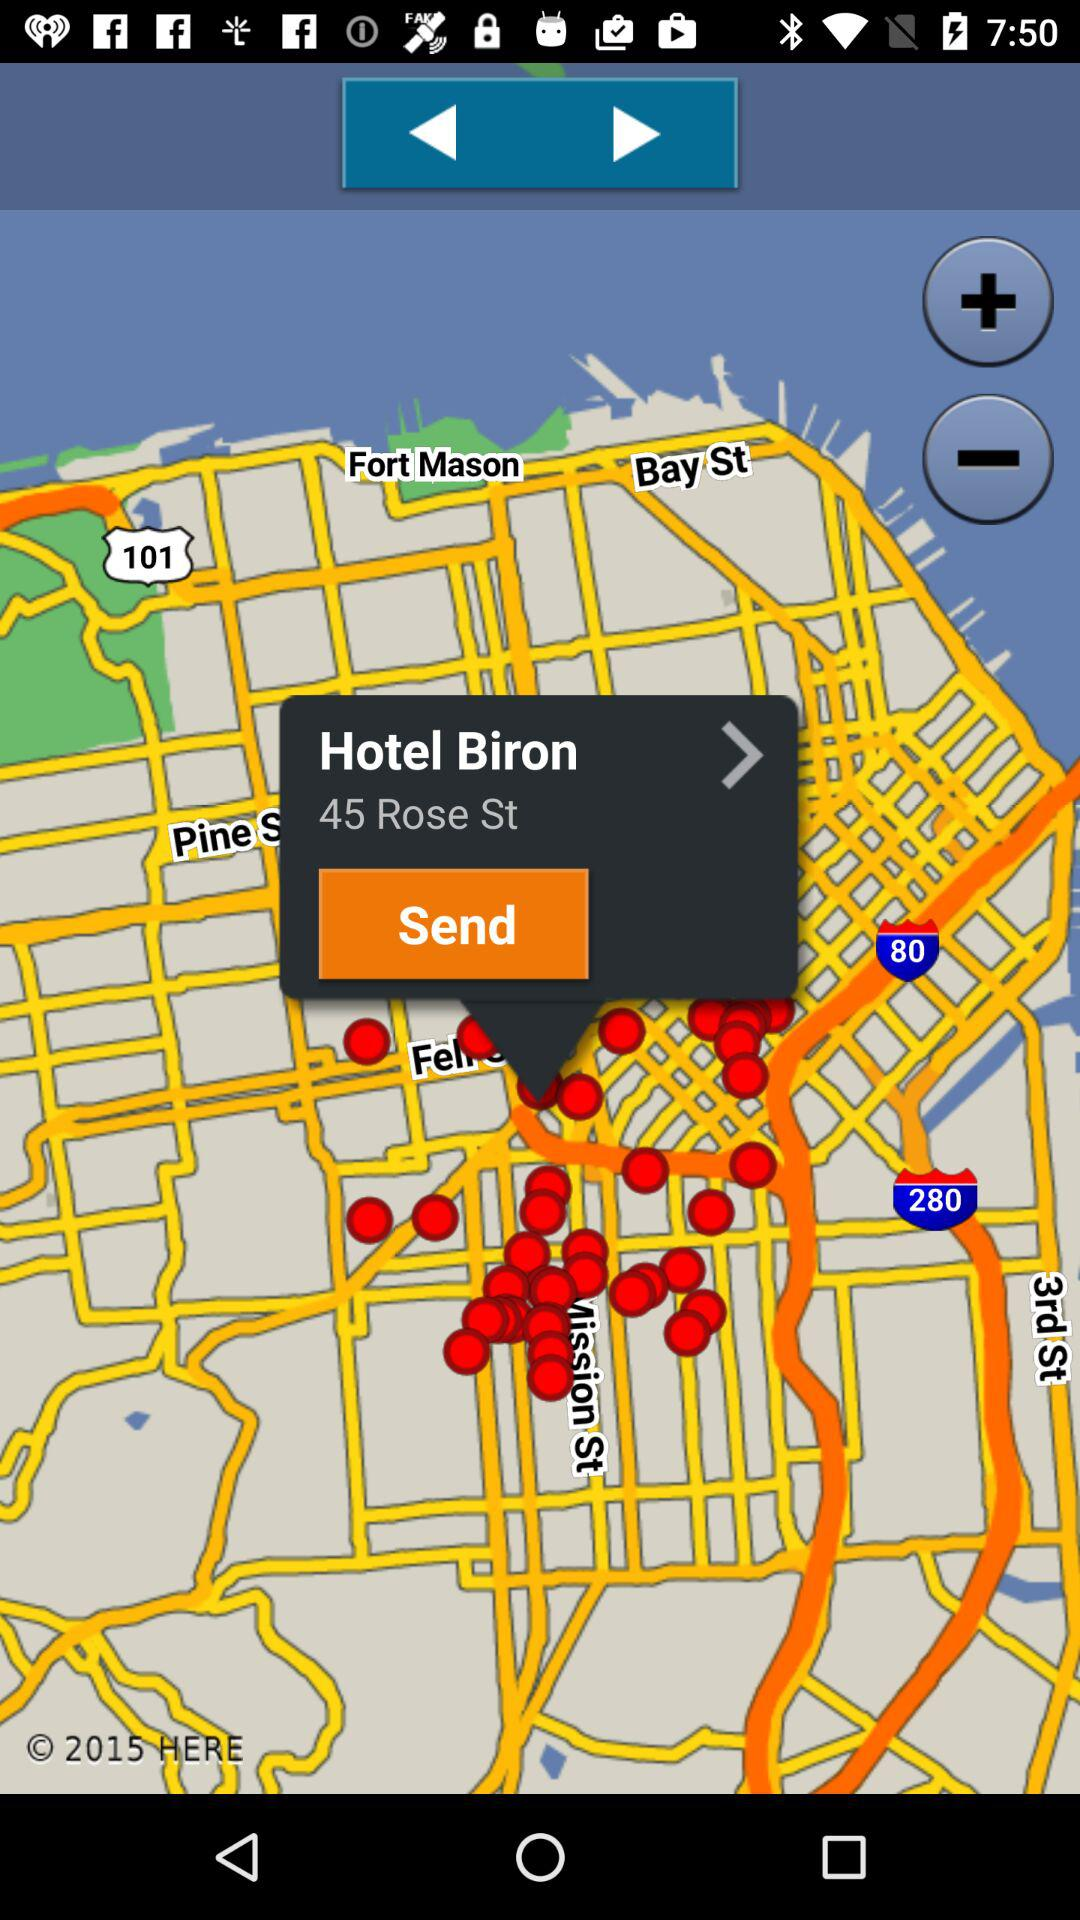What is the address of the hotel? The address of the hotel is 45 Rose St. 